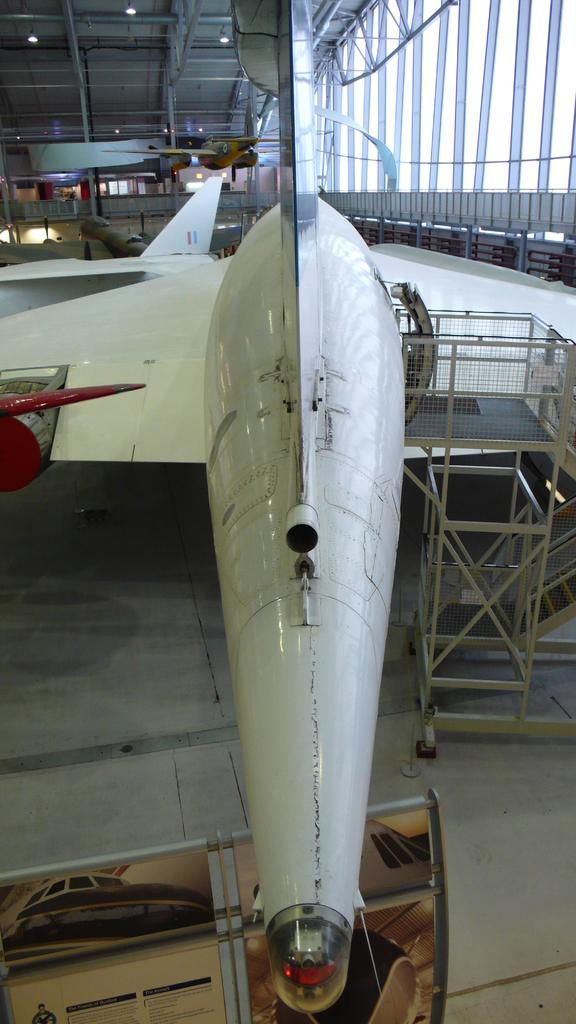What is the main subject in the center of the image? There is an aircraft in the center of the image. What part of the aircraft can be seen in the image? The floor is visible at the bottom of the image. What can be seen in the background of the image? There are windows in the background of the image. What is present on the roof of the aircraft in the image? The roof is visible in the image, and it has lights. What type of fish can be seen swimming near the aircraft in the image? There are no fish present in the image; it features an aircraft with a visible floor, windows, and roof lights. 